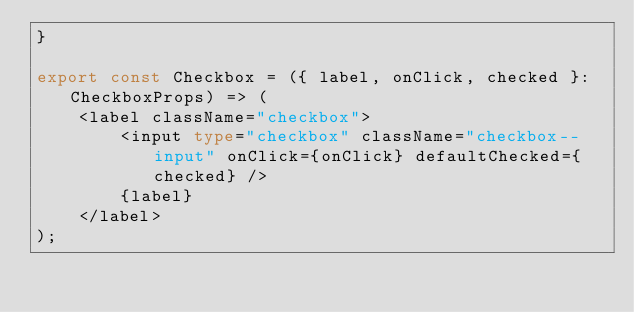Convert code to text. <code><loc_0><loc_0><loc_500><loc_500><_TypeScript_>}

export const Checkbox = ({ label, onClick, checked }: CheckboxProps) => (
    <label className="checkbox">
        <input type="checkbox" className="checkbox--input" onClick={onClick} defaultChecked={checked} />
        {label}
    </label>
);
</code> 